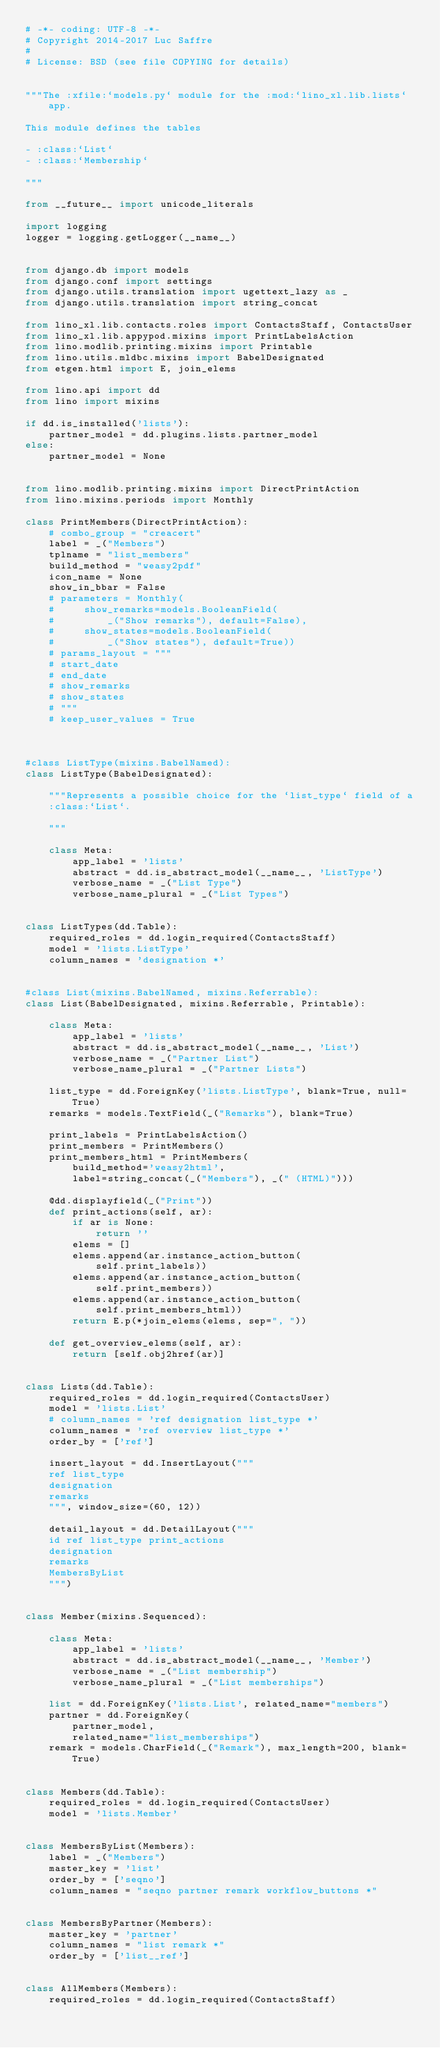Convert code to text. <code><loc_0><loc_0><loc_500><loc_500><_Python_># -*- coding: UTF-8 -*-
# Copyright 2014-2017 Luc Saffre
#
# License: BSD (see file COPYING for details)


"""The :xfile:`models.py` module for the :mod:`lino_xl.lib.lists` app.

This module defines the tables

- :class:`List`
- :class:`Membership`

"""

from __future__ import unicode_literals

import logging
logger = logging.getLogger(__name__)


from django.db import models
from django.conf import settings
from django.utils.translation import ugettext_lazy as _
from django.utils.translation import string_concat

from lino_xl.lib.contacts.roles import ContactsStaff, ContactsUser
from lino_xl.lib.appypod.mixins import PrintLabelsAction
from lino.modlib.printing.mixins import Printable
from lino.utils.mldbc.mixins import BabelDesignated
from etgen.html import E, join_elems

from lino.api import dd
from lino import mixins

if dd.is_installed('lists'):
    partner_model = dd.plugins.lists.partner_model
else:
    partner_model = None


from lino.modlib.printing.mixins import DirectPrintAction
from lino.mixins.periods import Monthly

class PrintMembers(DirectPrintAction):
    # combo_group = "creacert"
    label = _("Members")
    tplname = "list_members"
    build_method = "weasy2pdf"
    icon_name = None
    show_in_bbar = False
    # parameters = Monthly(
    #     show_remarks=models.BooleanField(
    #         _("Show remarks"), default=False),
    #     show_states=models.BooleanField(
    #         _("Show states"), default=True))
    # params_layout = """
    # start_date
    # end_date
    # show_remarks
    # show_states
    # """
    # keep_user_values = True

    

#class ListType(mixins.BabelNamed):
class ListType(BabelDesignated):

    """Represents a possible choice for the `list_type` field of a
    :class:`List`.

    """

    class Meta:
        app_label = 'lists'
        abstract = dd.is_abstract_model(__name__, 'ListType')
        verbose_name = _("List Type")
        verbose_name_plural = _("List Types")


class ListTypes(dd.Table):
    required_roles = dd.login_required(ContactsStaff)
    model = 'lists.ListType'
    column_names = 'designation *'


#class List(mixins.BabelNamed, mixins.Referrable):
class List(BabelDesignated, mixins.Referrable, Printable):

    class Meta:
        app_label = 'lists'
        abstract = dd.is_abstract_model(__name__, 'List')
        verbose_name = _("Partner List")
        verbose_name_plural = _("Partner Lists")

    list_type = dd.ForeignKey('lists.ListType', blank=True, null=True)
    remarks = models.TextField(_("Remarks"), blank=True)

    print_labels = PrintLabelsAction()
    print_members = PrintMembers()
    print_members_html = PrintMembers(
        build_method='weasy2html',
        label=string_concat(_("Members"), _(" (HTML)")))

    @dd.displayfield(_("Print"))
    def print_actions(self, ar):
        if ar is None:
            return ''
        elems = []
        elems.append(ar.instance_action_button(
            self.print_labels))
        elems.append(ar.instance_action_button(
            self.print_members))
        elems.append(ar.instance_action_button(
            self.print_members_html))
        return E.p(*join_elems(elems, sep=", "))

    def get_overview_elems(self, ar):
        return [self.obj2href(ar)]


class Lists(dd.Table):
    required_roles = dd.login_required(ContactsUser)
    model = 'lists.List'
    # column_names = 'ref designation list_type *'
    column_names = 'ref overview list_type *'
    order_by = ['ref']

    insert_layout = dd.InsertLayout("""
    ref list_type
    designation
    remarks
    """, window_size=(60, 12))

    detail_layout = dd.DetailLayout("""
    id ref list_type print_actions
    designation 
    remarks
    MembersByList
    """)


class Member(mixins.Sequenced):

    class Meta:
        app_label = 'lists'
        abstract = dd.is_abstract_model(__name__, 'Member')
        verbose_name = _("List membership")
        verbose_name_plural = _("List memberships")

    list = dd.ForeignKey('lists.List', related_name="members")
    partner = dd.ForeignKey(
        partner_model,
        related_name="list_memberships")
    remark = models.CharField(_("Remark"), max_length=200, blank=True)


class Members(dd.Table):
    required_roles = dd.login_required(ContactsUser)
    model = 'lists.Member'


class MembersByList(Members):
    label = _("Members")
    master_key = 'list'
    order_by = ['seqno']
    column_names = "seqno partner remark workflow_buttons *"


class MembersByPartner(Members):
    master_key = 'partner'
    column_names = "list remark *"
    order_by = ['list__ref']


class AllMembers(Members):
    required_roles = dd.login_required(ContactsStaff)


</code> 